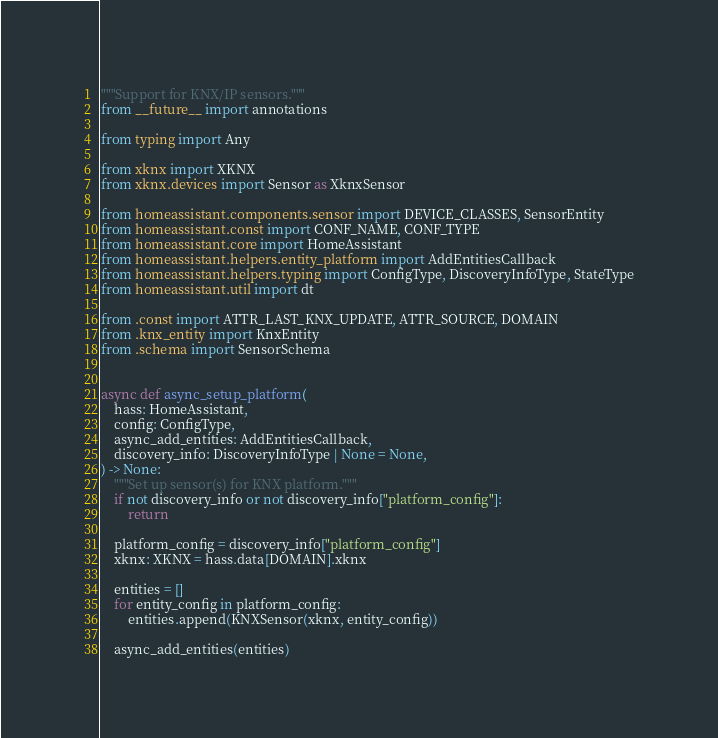<code> <loc_0><loc_0><loc_500><loc_500><_Python_>"""Support for KNX/IP sensors."""
from __future__ import annotations

from typing import Any

from xknx import XKNX
from xknx.devices import Sensor as XknxSensor

from homeassistant.components.sensor import DEVICE_CLASSES, SensorEntity
from homeassistant.const import CONF_NAME, CONF_TYPE
from homeassistant.core import HomeAssistant
from homeassistant.helpers.entity_platform import AddEntitiesCallback
from homeassistant.helpers.typing import ConfigType, DiscoveryInfoType, StateType
from homeassistant.util import dt

from .const import ATTR_LAST_KNX_UPDATE, ATTR_SOURCE, DOMAIN
from .knx_entity import KnxEntity
from .schema import SensorSchema


async def async_setup_platform(
    hass: HomeAssistant,
    config: ConfigType,
    async_add_entities: AddEntitiesCallback,
    discovery_info: DiscoveryInfoType | None = None,
) -> None:
    """Set up sensor(s) for KNX platform."""
    if not discovery_info or not discovery_info["platform_config"]:
        return

    platform_config = discovery_info["platform_config"]
    xknx: XKNX = hass.data[DOMAIN].xknx

    entities = []
    for entity_config in platform_config:
        entities.append(KNXSensor(xknx, entity_config))

    async_add_entities(entities)

</code> 